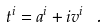<formula> <loc_0><loc_0><loc_500><loc_500>t ^ { i } = a ^ { i } + i v ^ { i } \ .</formula> 